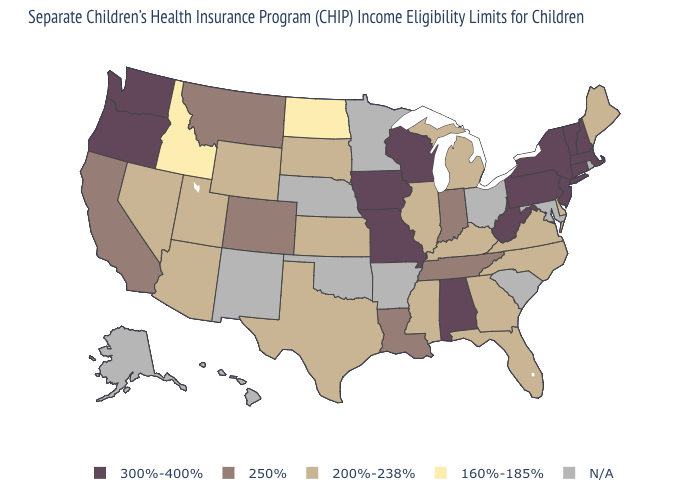What is the highest value in states that border Mississippi?
Give a very brief answer. 300%-400%. What is the value of Maine?
Quick response, please. 200%-238%. What is the value of Montana?
Answer briefly. 250%. Which states have the highest value in the USA?
Answer briefly. Alabama, Connecticut, Iowa, Massachusetts, Missouri, New Hampshire, New Jersey, New York, Oregon, Pennsylvania, Vermont, Washington, West Virginia, Wisconsin. Does Pennsylvania have the highest value in the USA?
Write a very short answer. Yes. What is the lowest value in states that border California?
Quick response, please. 200%-238%. Which states have the lowest value in the West?
Quick response, please. Idaho. What is the value of Florida?
Answer briefly. 200%-238%. What is the highest value in states that border Montana?
Short answer required. 200%-238%. What is the highest value in states that border South Carolina?
Quick response, please. 200%-238%. What is the value of Iowa?
Write a very short answer. 300%-400%. What is the value of Georgia?
Concise answer only. 200%-238%. What is the lowest value in states that border Louisiana?
Concise answer only. 200%-238%. 